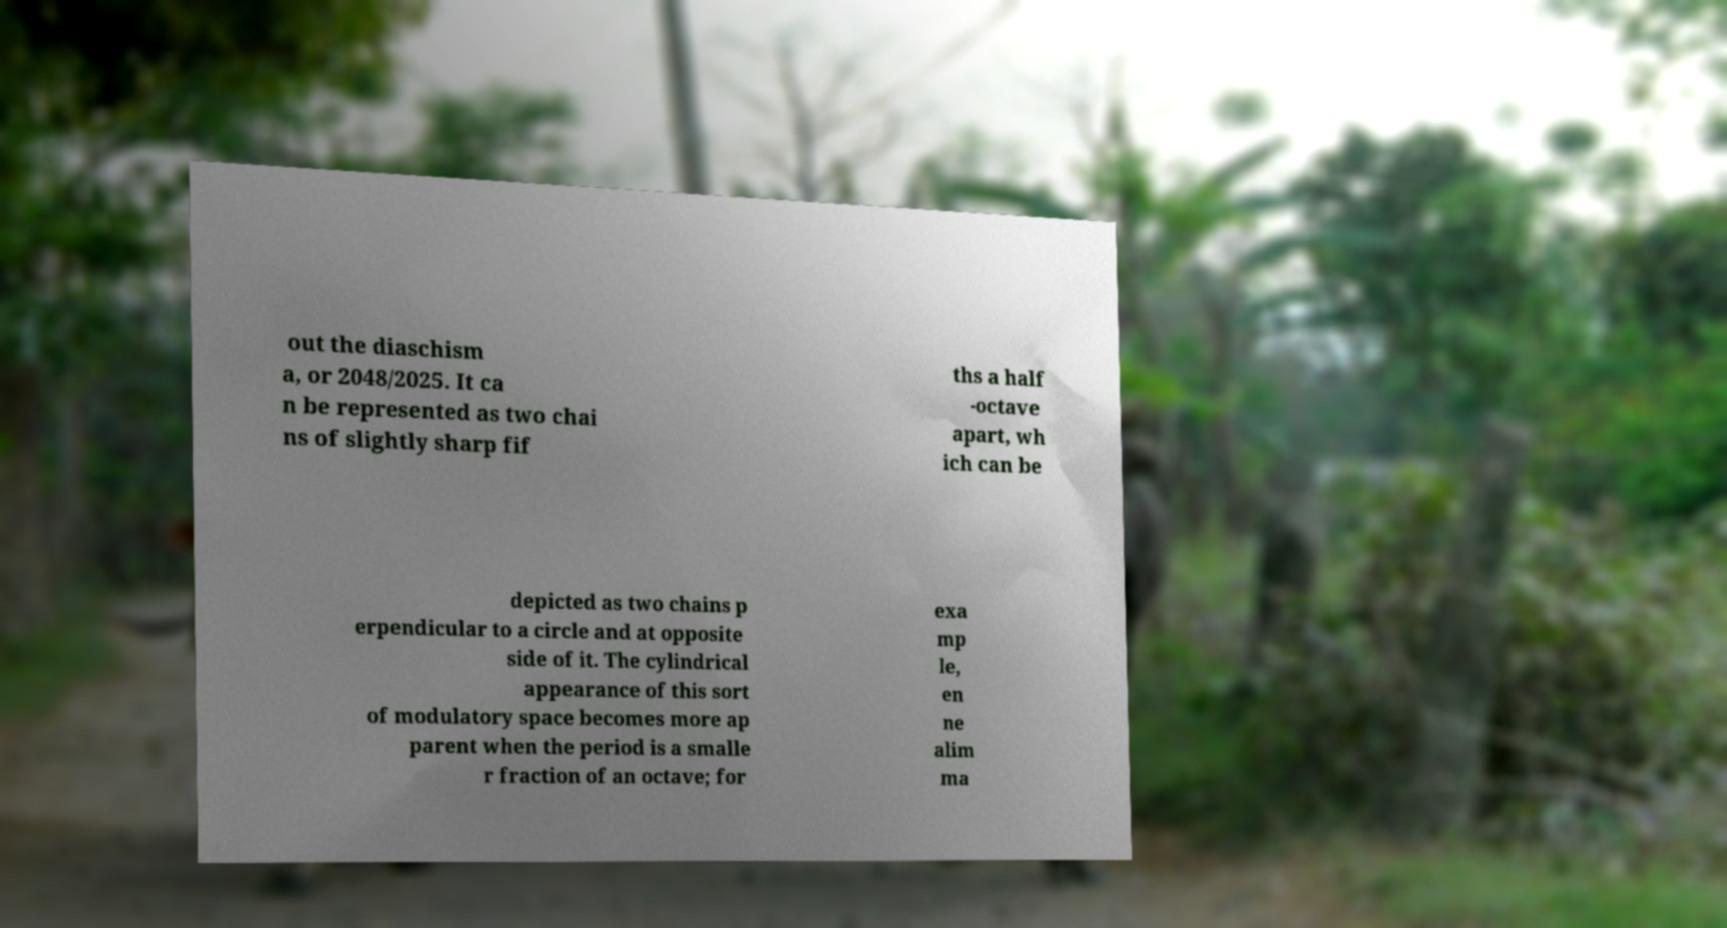Could you assist in decoding the text presented in this image and type it out clearly? out the diaschism a, or 2048/2025. It ca n be represented as two chai ns of slightly sharp fif ths a half -octave apart, wh ich can be depicted as two chains p erpendicular to a circle and at opposite side of it. The cylindrical appearance of this sort of modulatory space becomes more ap parent when the period is a smalle r fraction of an octave; for exa mp le, en ne alim ma 